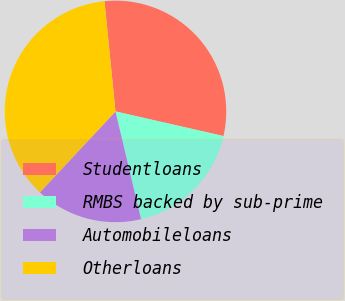Convert chart to OTSL. <chart><loc_0><loc_0><loc_500><loc_500><pie_chart><fcel>Studentloans<fcel>RMBS backed by sub-prime<fcel>Automobileloans<fcel>Otherloans<nl><fcel>30.15%<fcel>17.73%<fcel>15.65%<fcel>36.46%<nl></chart> 